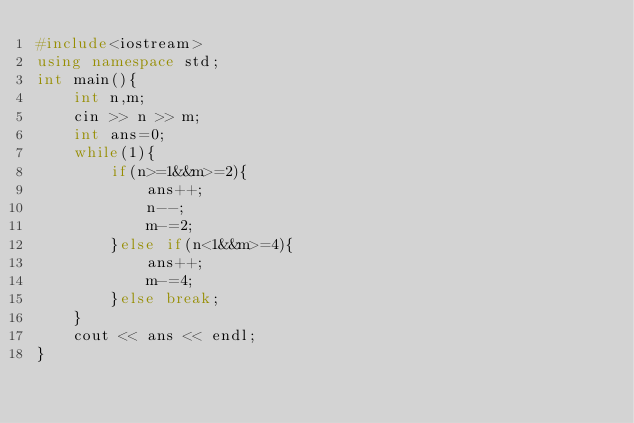<code> <loc_0><loc_0><loc_500><loc_500><_C++_>#include<iostream>
using namespace std;
int main(){
	int n,m;
	cin >> n >> m;
	int ans=0;
	while(1){
		if(n>=1&&m>=2){
			ans++;
			n--;
			m-=2;
		}else if(n<1&&m>=4){
			ans++;
			m-=4;
		}else break;
	}
	cout << ans << endl;
}
</code> 